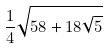Convert formula to latex. <formula><loc_0><loc_0><loc_500><loc_500>\frac { 1 } { 4 } \sqrt { 5 8 + 1 8 \sqrt { 5 } }</formula> 